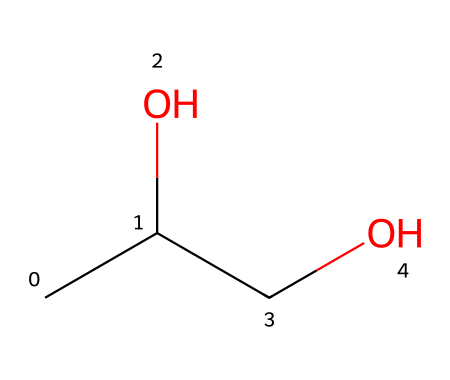What is the total number of carbon atoms in propylene glycol? By analyzing the SMILES notation, "CC(O)CO", we can see that there are three groups representing carbon atoms: one from the "C" at the start, one from the next "C", and one from the "C" before "O". Hence, the total is three.
Answer: three How many oxygen atoms are present in the structure of propylene glycol? The SMILES notation shows one "O" directly after a "C", and one "O" at the end of the notation (as part of the "C(O)CO" structure). Thus, there are two oxygen atoms in the compound.
Answer: two What is the functional group present in propylene glycol? The hydroxyl group "OH" attached to one of the carbon atoms indicates that propylene glycol belongs to the alcohol functional group category. The presence of "O" connected to a hydrogen indicates this functionality.
Answer: alcohol What is the degree of saturation of propylene glycol? The presence of varying bonds between the carbon and hydrogen indicates it is saturated; therefore, there are no double or triple bonds between any of the carbon atoms. This conclusion can be drawn by examining the bonds represented in the SMILES.
Answer: saturated Does propylene glycol have a branched or straight-chain structure? The arrangement "CC(O)CO" indicates that the carbon atoms create a linear chain without any branching points; therefore, it represents a straight-chain structure.
Answer: straight-chain What type of food additive is propylene glycol categorized as? Propylene glycol, used as a humectant in food, is categorized specifically as a food additive due to its properties of retaining moisture, as can be inferred from its application in semi-moist pet foods.
Answer: humectant 